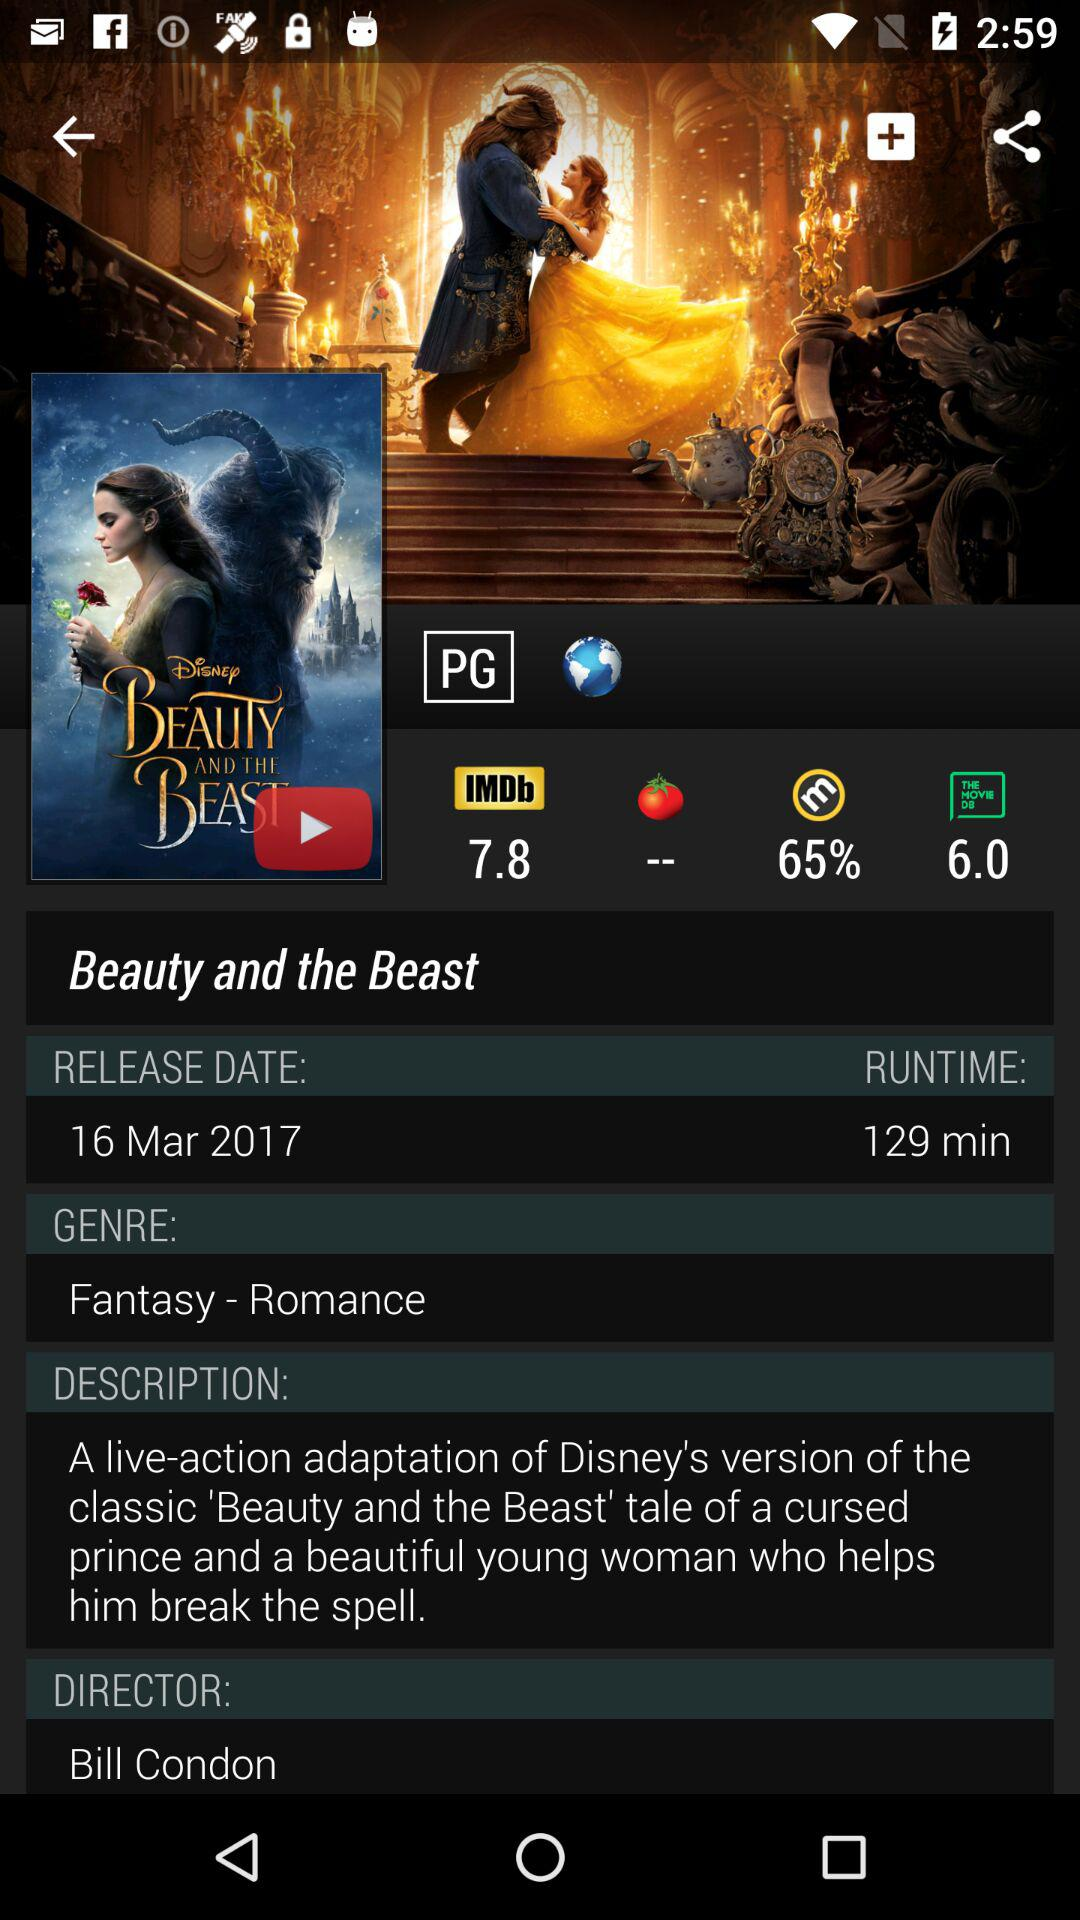What is the runtime of "Beauty and the Beast"? The runtime is 129 minutes. 